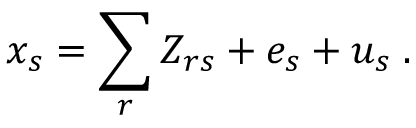Convert formula to latex. <formula><loc_0><loc_0><loc_500><loc_500>x _ { s } = \sum _ { r } Z _ { r s } + e _ { s } + u _ { s } \, .</formula> 